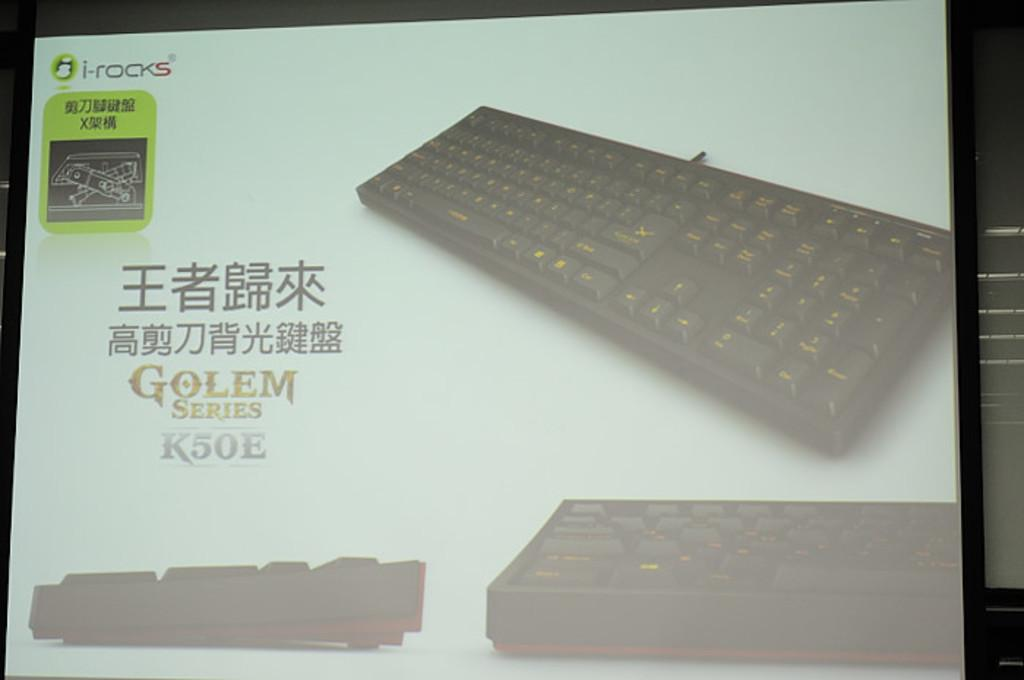<image>
Render a clear and concise summary of the photo. The box for an i-rocks keyboard that has Asian writing on it. 